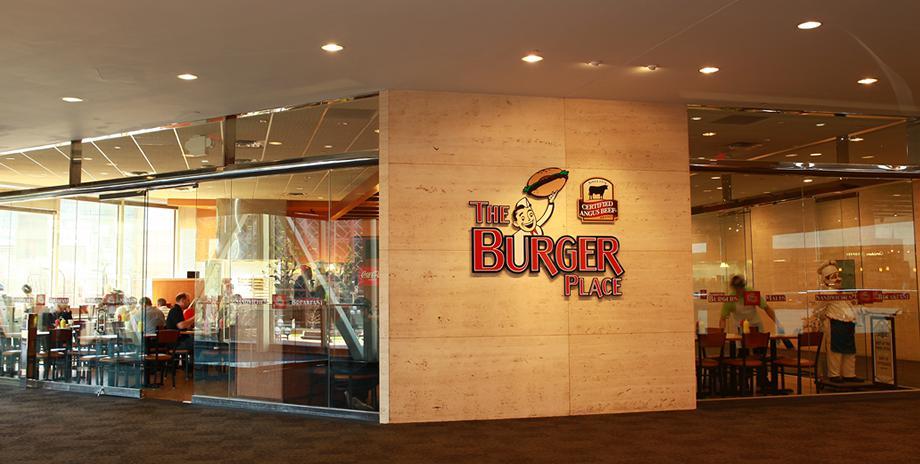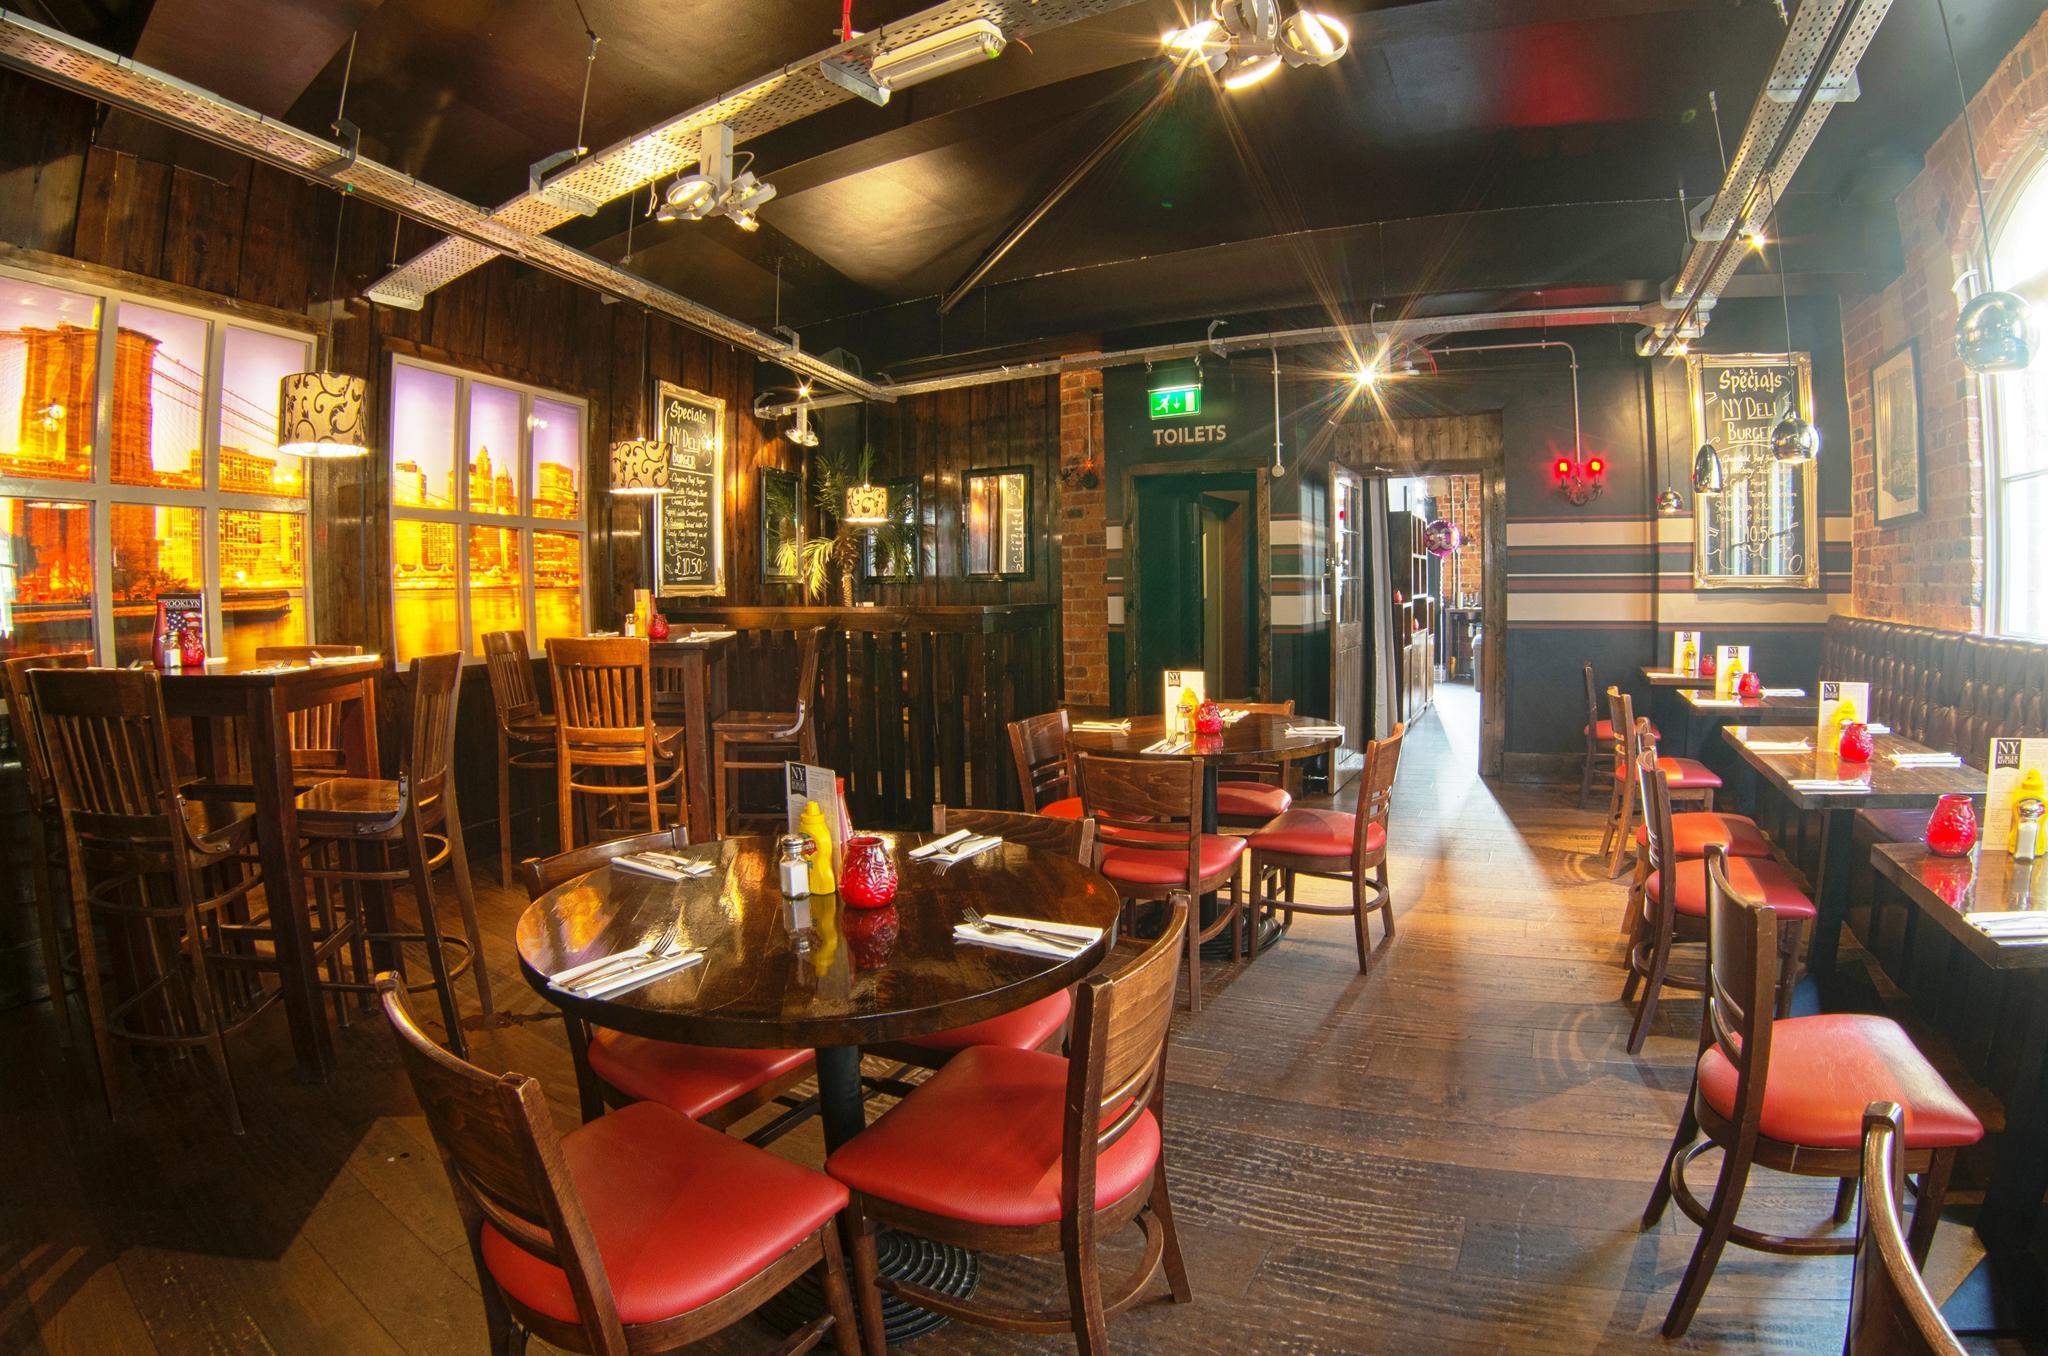The first image is the image on the left, the second image is the image on the right. Evaluate the accuracy of this statement regarding the images: "There are people in the right image but not in the left image.". Is it true? Answer yes or no. No. The first image is the image on the left, the second image is the image on the right. Analyze the images presented: Is the assertion "There are two restaurants will all of its seats empty." valid? Answer yes or no. No. 